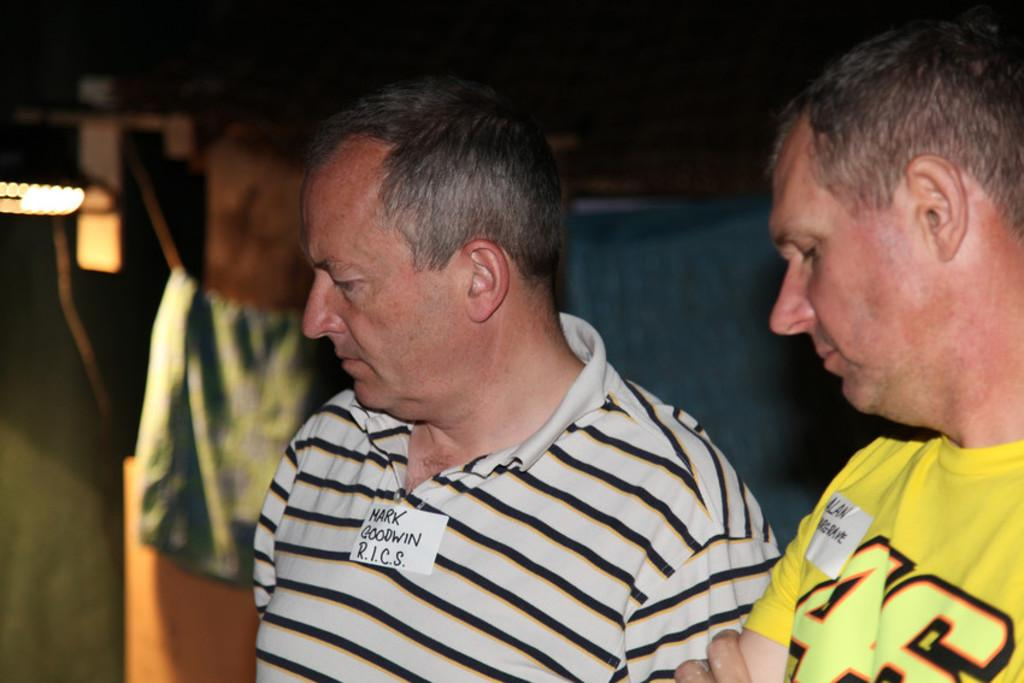How many people are in the image? There are two persons in the image. What can be seen behind the persons? There are objects behind the persons. Where is the light source located in the image? The light is on the left side of the image. What type of nail is being hammered by the persons in the image? There is no nail or hammering activity present in the image. What kind of club is being used by the persons in the image? There is no club or club-related activity present in the image. 